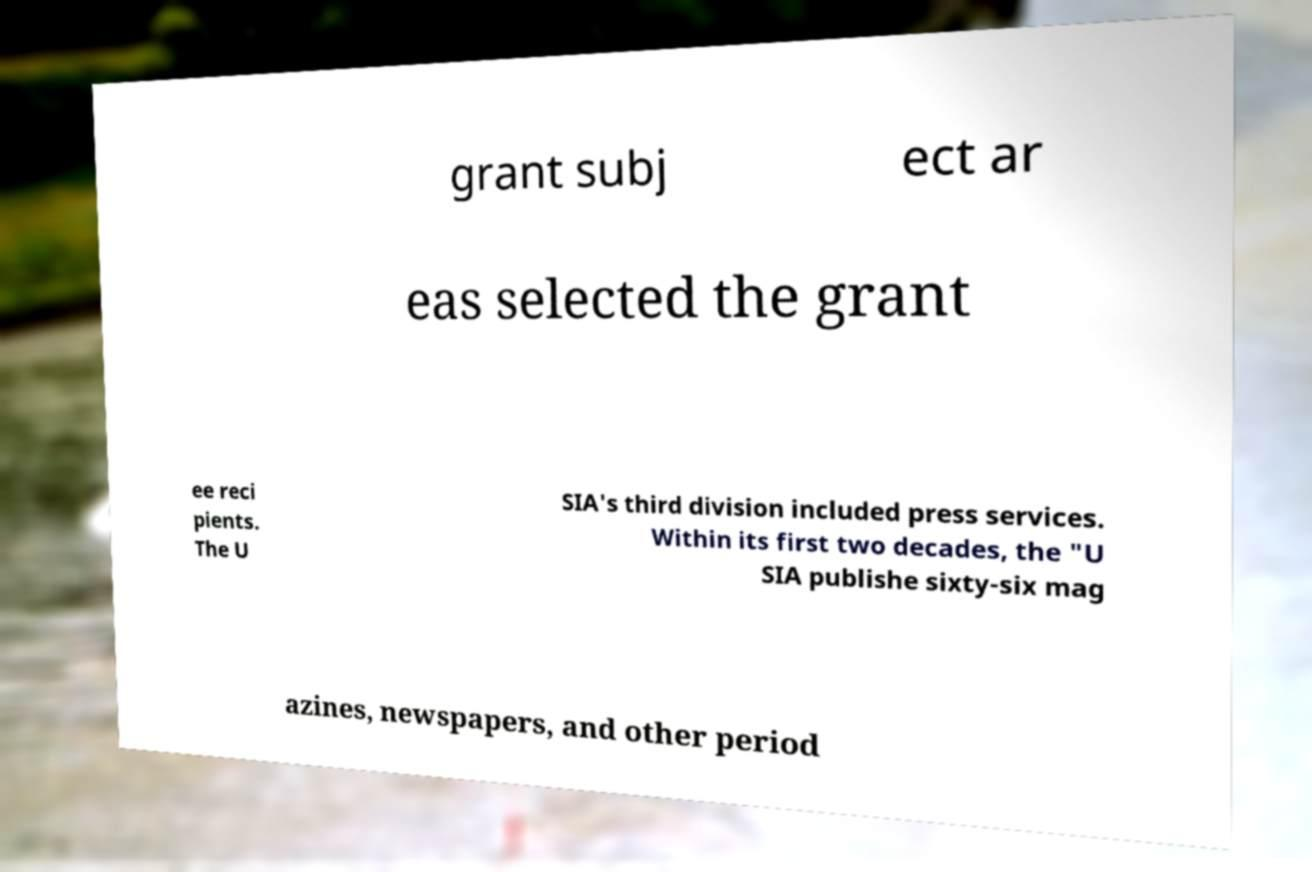Can you accurately transcribe the text from the provided image for me? grant subj ect ar eas selected the grant ee reci pients. The U SIA's third division included press services. Within its first two decades, the "U SIA publishe sixty-six mag azines, newspapers, and other period 